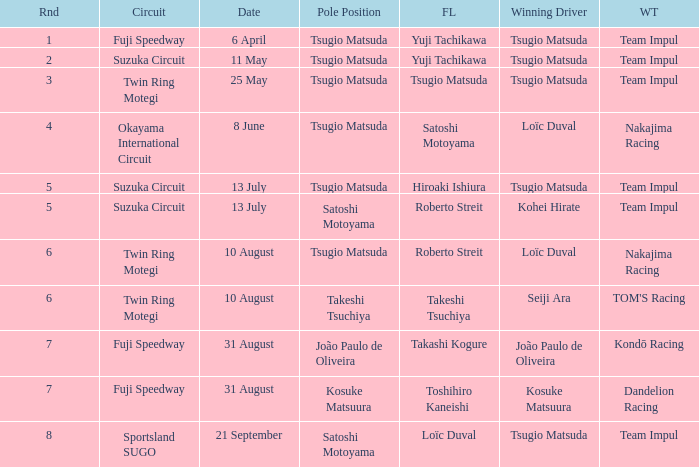On what date does Yuji Tachikawa have the fastest lap in round 1? 6 April. 